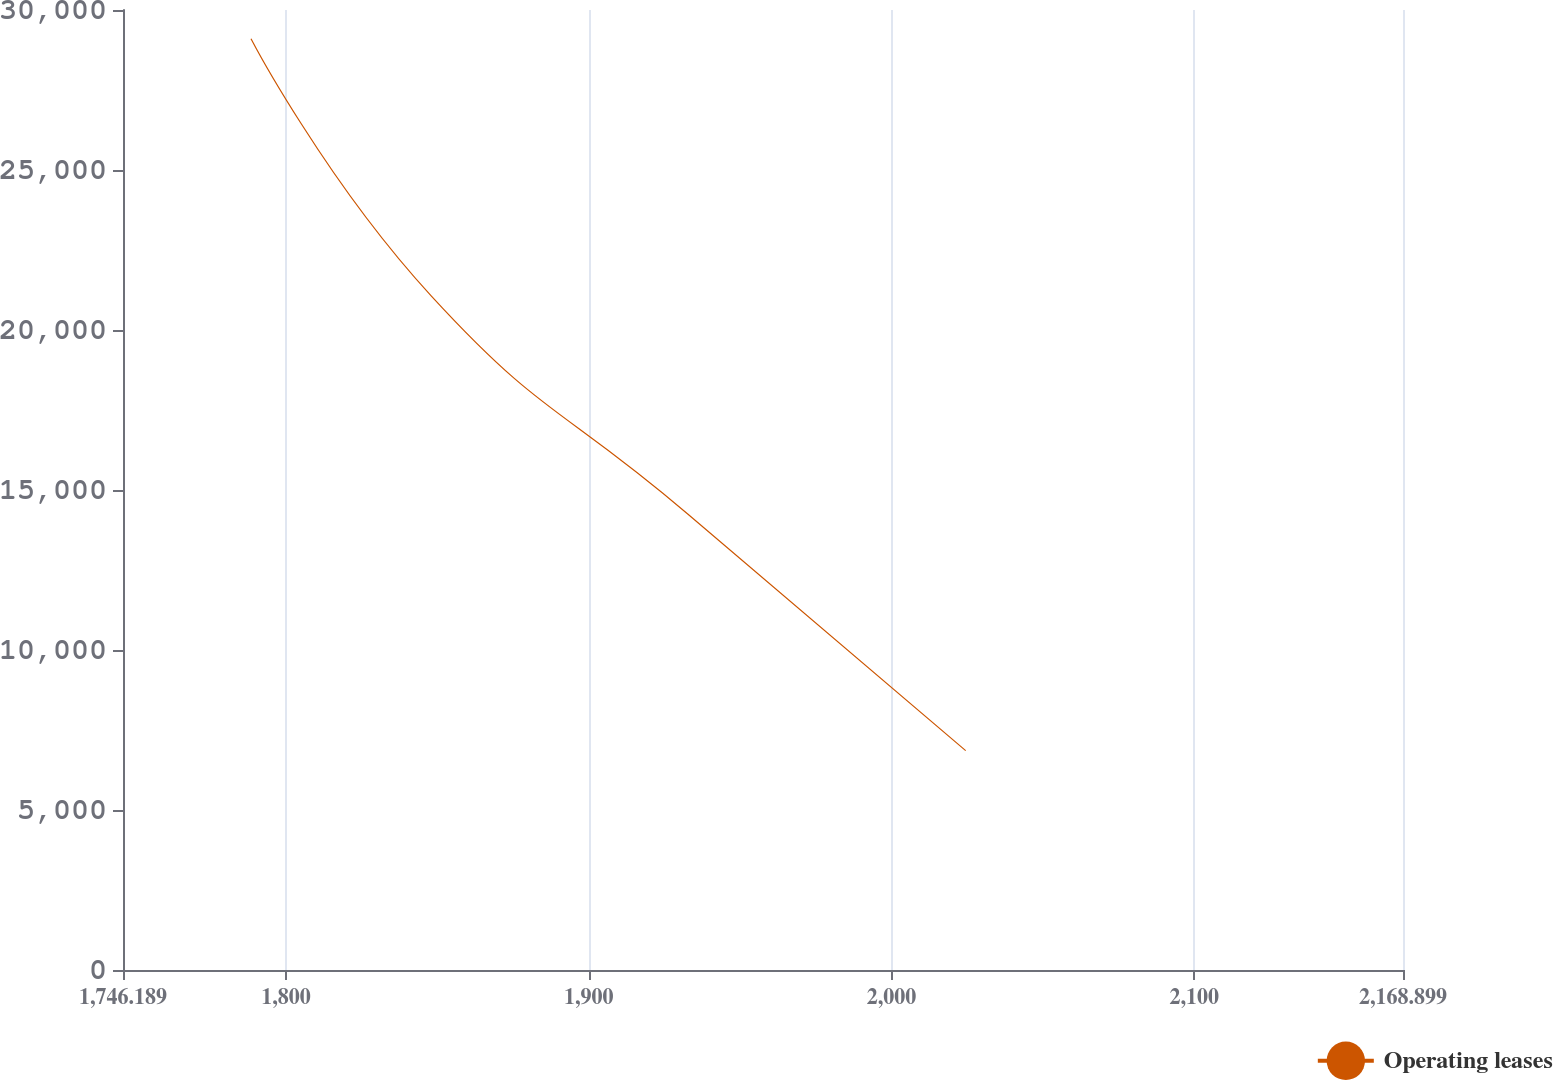Convert chart to OTSL. <chart><loc_0><loc_0><loc_500><loc_500><line_chart><ecel><fcel>Operating leases<nl><fcel>1788.46<fcel>29104.5<nl><fcel>1847.96<fcel>21067.5<nl><fcel>1932.88<fcel>14236.7<nl><fcel>2024.48<fcel>6856.76<nl><fcel>2211.17<fcel>3470.95<nl></chart> 